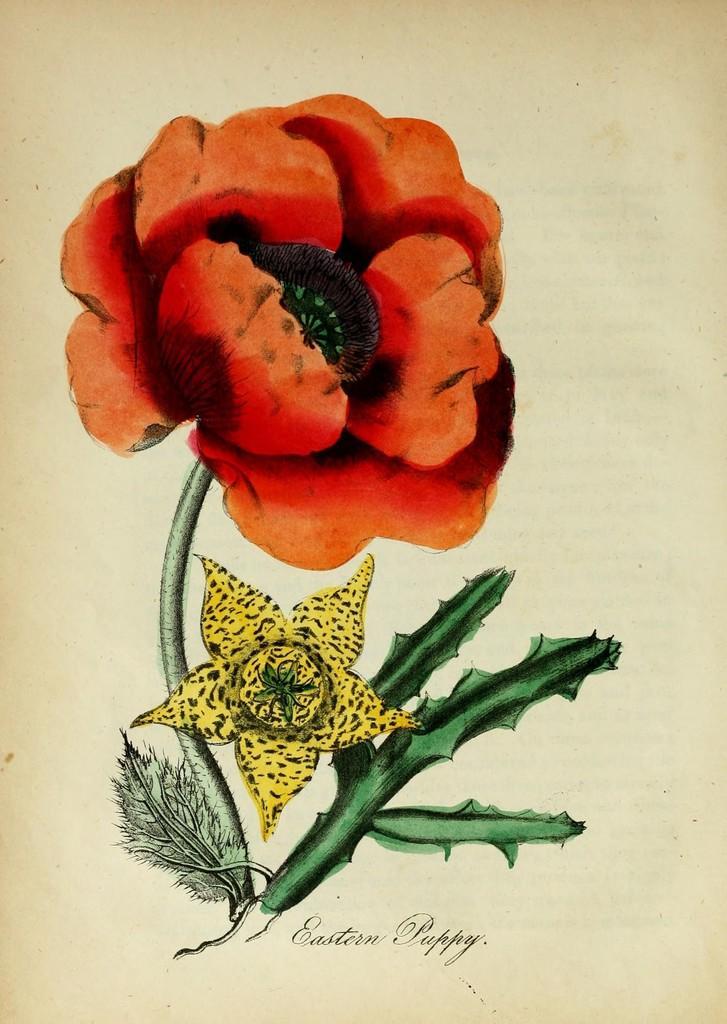Please provide a concise description of this image. In this image I can see a painting of flowers. I can see color of these flowers are orange and yellow. I can also see something is written over here. 